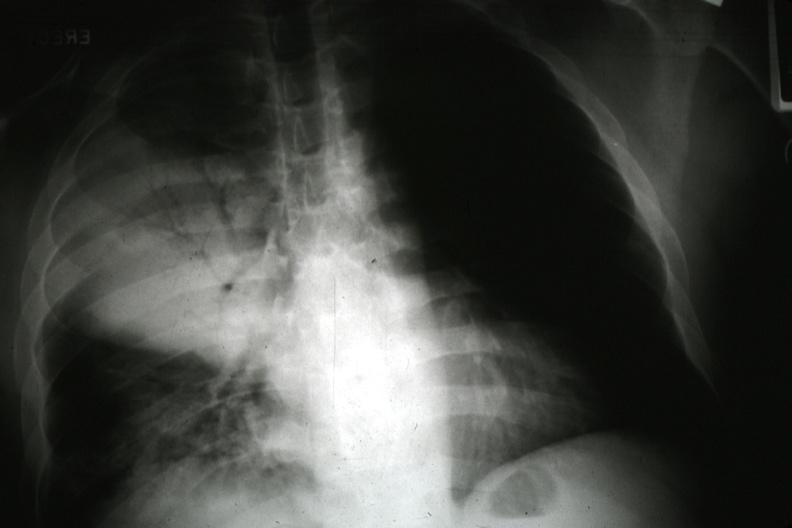s lung present?
Answer the question using a single word or phrase. Yes 